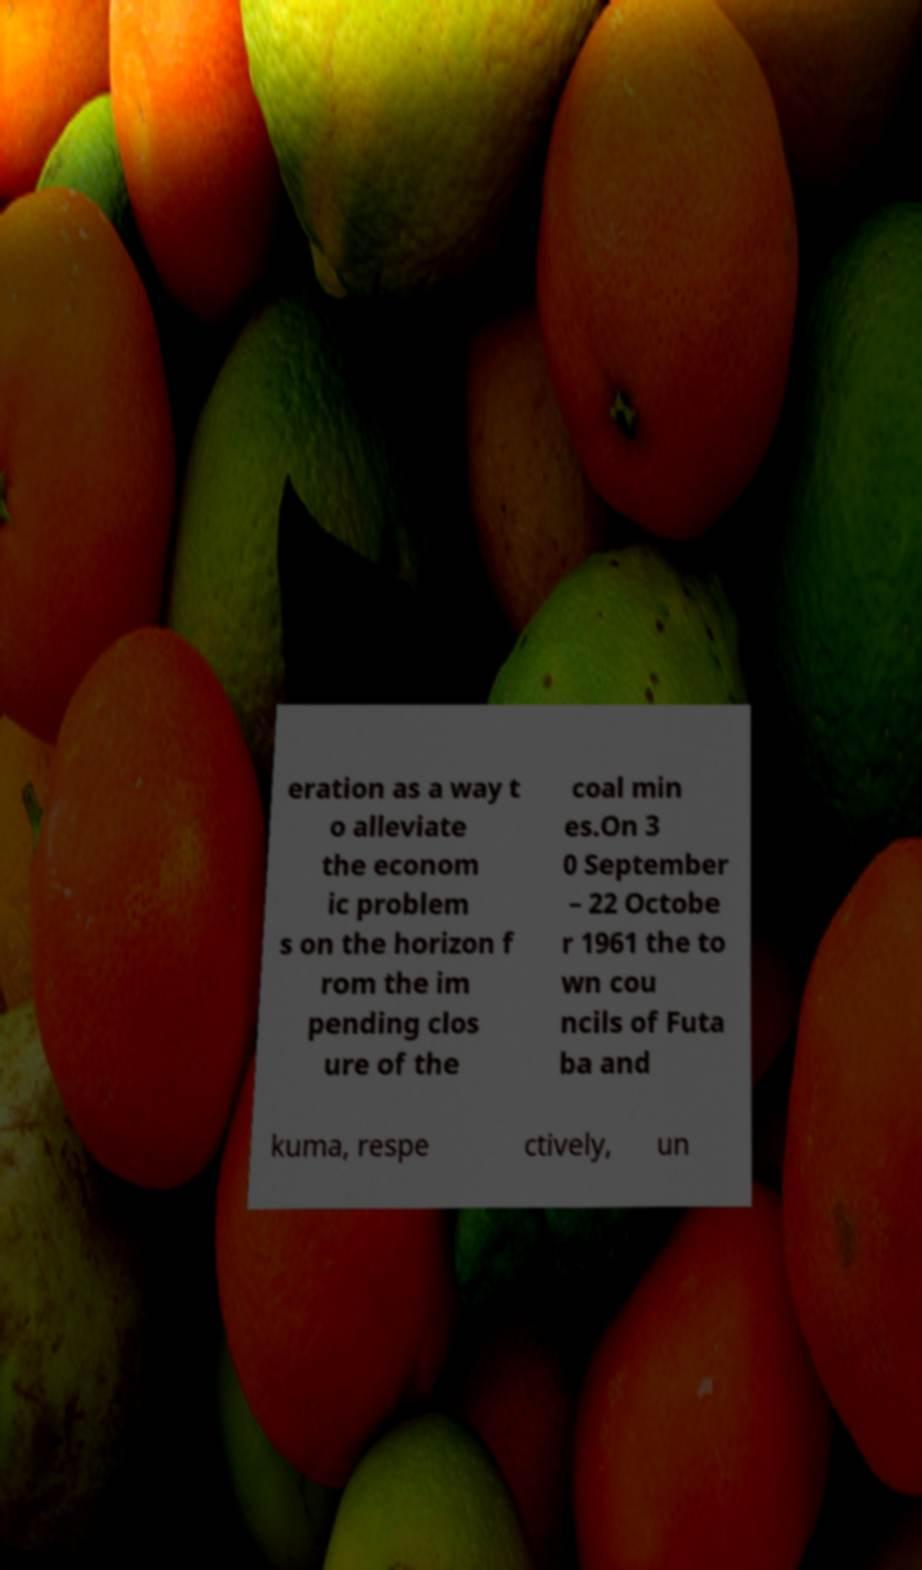There's text embedded in this image that I need extracted. Can you transcribe it verbatim? eration as a way t o alleviate the econom ic problem s on the horizon f rom the im pending clos ure of the coal min es.On 3 0 September – 22 Octobe r 1961 the to wn cou ncils of Futa ba and kuma, respe ctively, un 